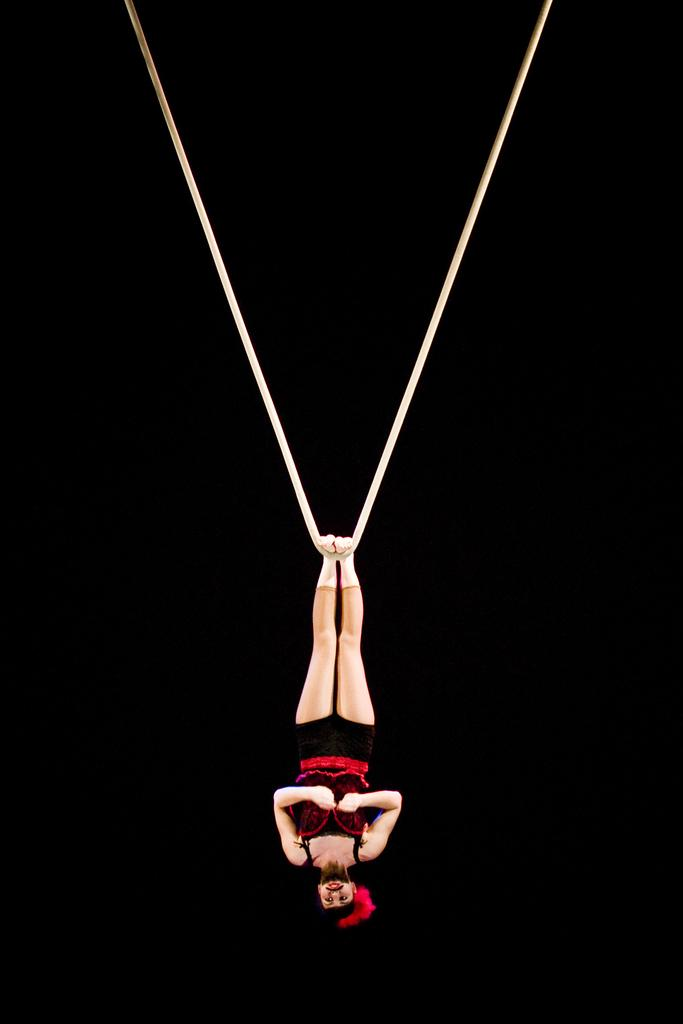What object can be seen in the image that is made of rope? There is a white color rope in the image. What is the woman in the image wearing? The woman is wearing a black and red color dress. What color can be seen in the background of the image? There is black color visible in the background of the image. How many balloons are tied to the woman's trousers in the image? There are no balloons or trousers present in the image. What type of activity is taking place at the cemetery in the image? There is no cemetery present in the image. 